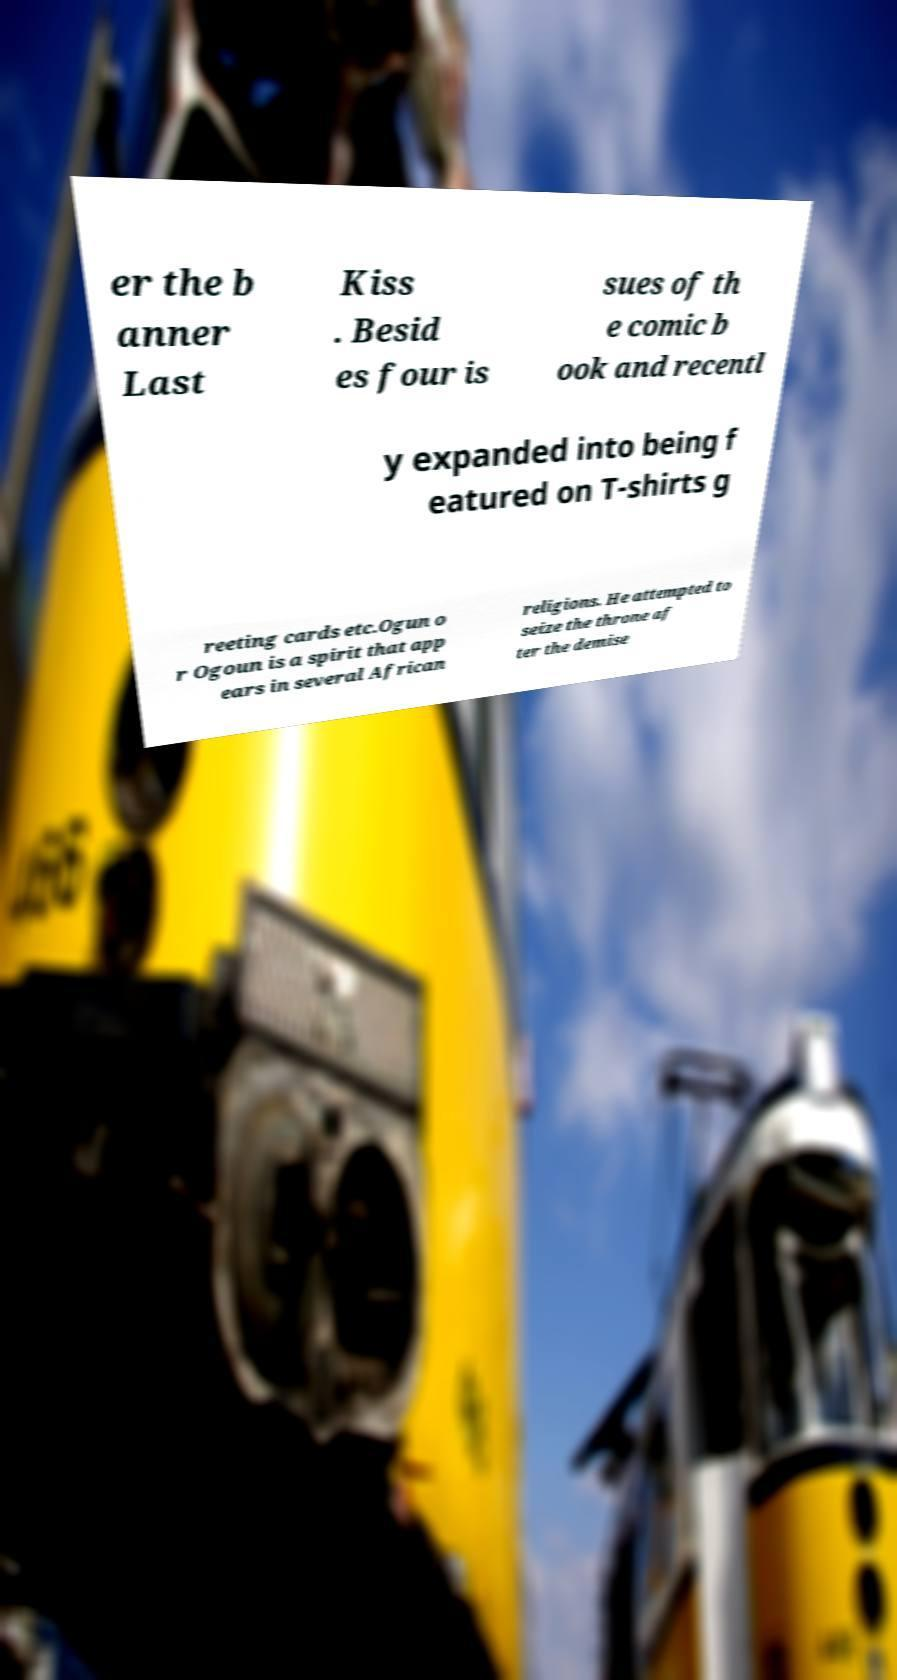What messages or text are displayed in this image? I need them in a readable, typed format. er the b anner Last Kiss . Besid es four is sues of th e comic b ook and recentl y expanded into being f eatured on T-shirts g reeting cards etc.Ogun o r Ogoun is a spirit that app ears in several African religions. He attempted to seize the throne af ter the demise 